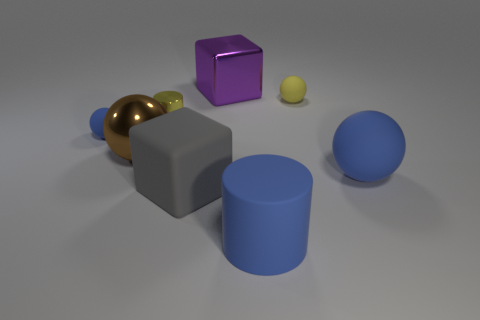Are there any small matte balls of the same color as the shiny sphere?
Make the answer very short. No. Are there any brown objects?
Offer a very short reply. Yes. There is a tiny rubber object that is on the left side of the large gray matte block; what shape is it?
Give a very brief answer. Sphere. What number of spheres are both behind the large matte sphere and in front of the tiny cylinder?
Ensure brevity in your answer.  2. What number of other things are the same size as the yellow metal cylinder?
Your answer should be compact. 2. Does the blue thing that is to the left of the blue cylinder have the same shape as the large thing that is behind the big brown shiny object?
Provide a short and direct response. No. What number of objects are small balls or blue rubber balls that are left of the large rubber cylinder?
Ensure brevity in your answer.  2. What is the material of the ball that is both in front of the tiny metallic cylinder and on the right side of the big gray matte cube?
Your answer should be very brief. Rubber. Is there any other thing that is the same shape as the gray thing?
Your answer should be very brief. Yes. There is a block that is the same material as the small yellow cylinder; what color is it?
Your answer should be very brief. Purple. 